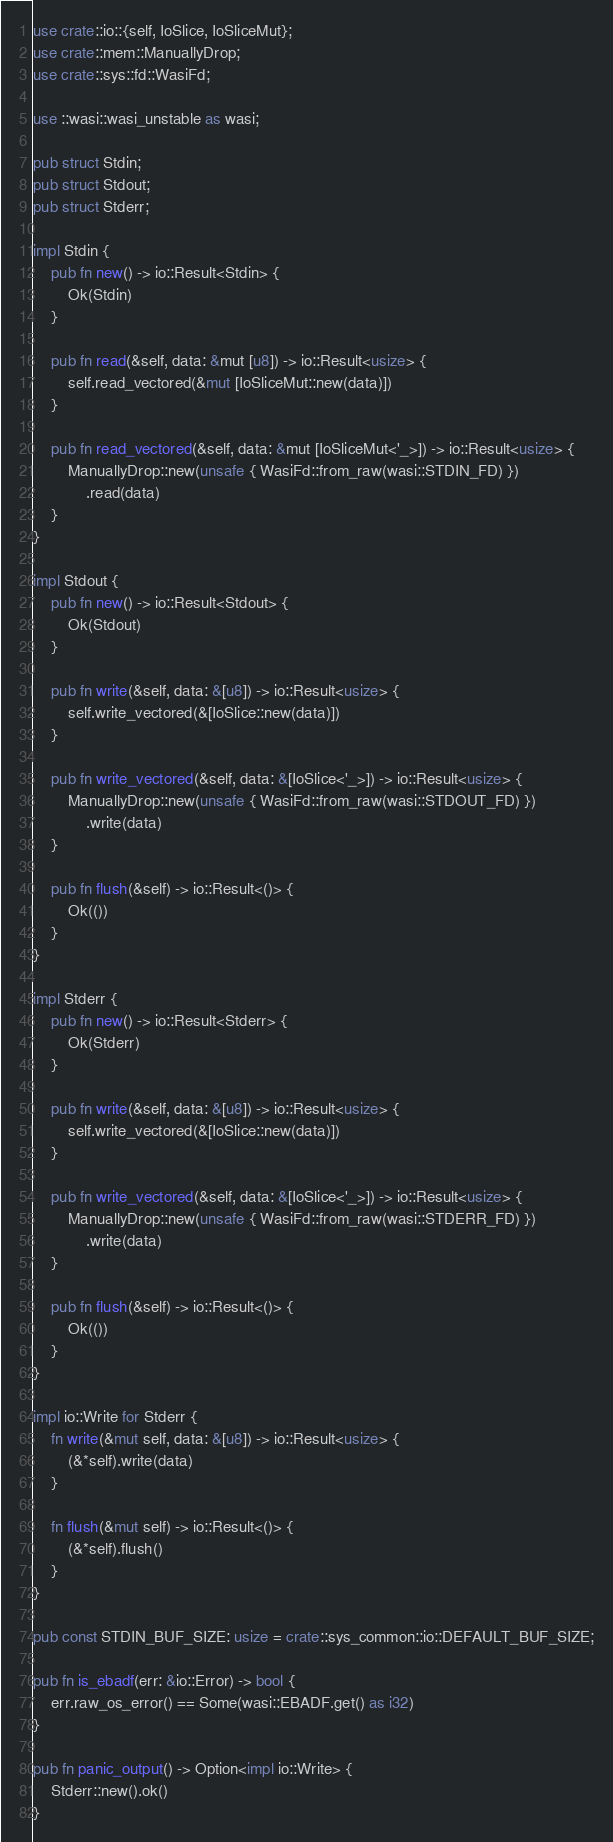Convert code to text. <code><loc_0><loc_0><loc_500><loc_500><_Rust_>use crate::io::{self, IoSlice, IoSliceMut};
use crate::mem::ManuallyDrop;
use crate::sys::fd::WasiFd;

use ::wasi::wasi_unstable as wasi;

pub struct Stdin;
pub struct Stdout;
pub struct Stderr;

impl Stdin {
    pub fn new() -> io::Result<Stdin> {
        Ok(Stdin)
    }

    pub fn read(&self, data: &mut [u8]) -> io::Result<usize> {
        self.read_vectored(&mut [IoSliceMut::new(data)])
    }

    pub fn read_vectored(&self, data: &mut [IoSliceMut<'_>]) -> io::Result<usize> {
        ManuallyDrop::new(unsafe { WasiFd::from_raw(wasi::STDIN_FD) })
            .read(data)
    }
}

impl Stdout {
    pub fn new() -> io::Result<Stdout> {
        Ok(Stdout)
    }

    pub fn write(&self, data: &[u8]) -> io::Result<usize> {
        self.write_vectored(&[IoSlice::new(data)])
    }

    pub fn write_vectored(&self, data: &[IoSlice<'_>]) -> io::Result<usize> {
        ManuallyDrop::new(unsafe { WasiFd::from_raw(wasi::STDOUT_FD) })
            .write(data)
    }

    pub fn flush(&self) -> io::Result<()> {
        Ok(())
    }
}

impl Stderr {
    pub fn new() -> io::Result<Stderr> {
        Ok(Stderr)
    }

    pub fn write(&self, data: &[u8]) -> io::Result<usize> {
        self.write_vectored(&[IoSlice::new(data)])
    }

    pub fn write_vectored(&self, data: &[IoSlice<'_>]) -> io::Result<usize> {
        ManuallyDrop::new(unsafe { WasiFd::from_raw(wasi::STDERR_FD) })
            .write(data)
    }

    pub fn flush(&self) -> io::Result<()> {
        Ok(())
    }
}

impl io::Write for Stderr {
    fn write(&mut self, data: &[u8]) -> io::Result<usize> {
        (&*self).write(data)
    }

    fn flush(&mut self) -> io::Result<()> {
        (&*self).flush()
    }
}

pub const STDIN_BUF_SIZE: usize = crate::sys_common::io::DEFAULT_BUF_SIZE;

pub fn is_ebadf(err: &io::Error) -> bool {
    err.raw_os_error() == Some(wasi::EBADF.get() as i32)
}

pub fn panic_output() -> Option<impl io::Write> {
    Stderr::new().ok()
}
</code> 